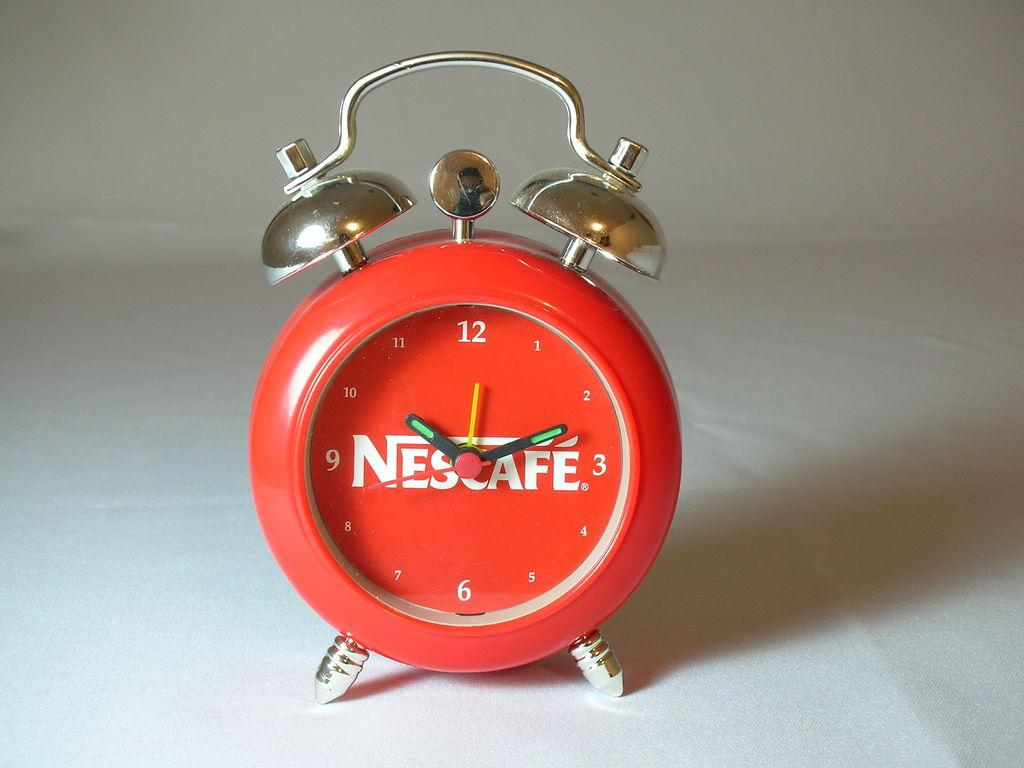What object can be seen in the image that is used for telling time? There is a clock in the image that is used for telling time. Where is the clock located in the image? The clock is on a table in the image. What is the color of the clock? The clock is red in color. What type of lipstick is the clock wearing in the image? The clock is not wearing lipstick, as it is an inanimate object and does not have lips. 